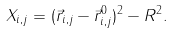<formula> <loc_0><loc_0><loc_500><loc_500>X _ { i , j } = ( \vec { r } _ { i , j } - \vec { r } ^ { 0 } _ { i , j } ) ^ { 2 } - R ^ { 2 } .</formula> 